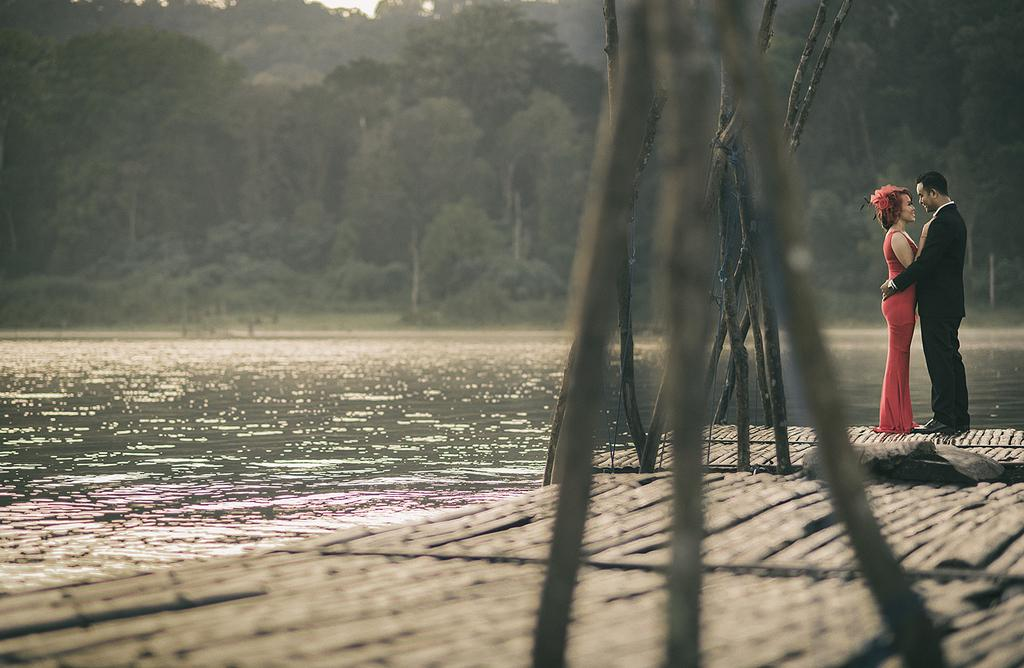Who can be seen standing on the right side of the image? There is a couple standing on the right side of the image. What is in front of the couple? There is a river in front of the couple. What can be seen in the background of the image? The sky is visible in the background of the image. What type of voice can be heard coming from the river in the image? There is no voice present in the image, as it is a still photograph. 